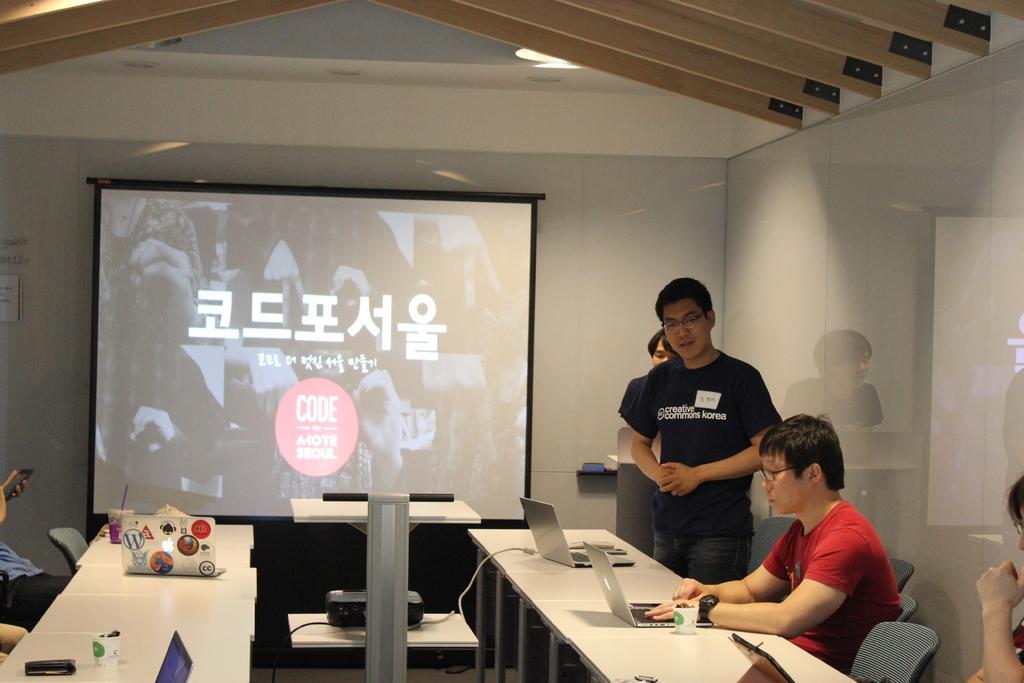Describe this image in one or two sentences. In this image there are people sitting on the chairs at the tables. On the table there are laptops, paper cups and glasses. In the background there is a wall. There is a projector board hanging on the wall. In front of the board there is projector on a table. Beside the bord there are two men standing. There is text displayed on the projector board. 